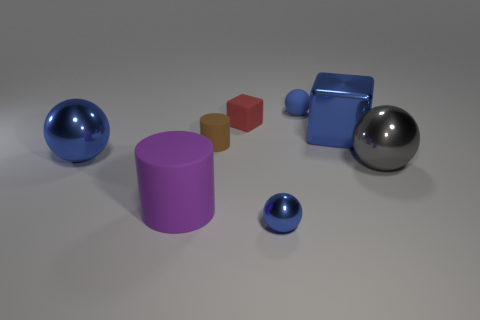What color is the large ball on the right side of the blue matte ball?
Provide a succinct answer. Gray. What number of objects are blue balls that are in front of the small red matte thing or big rubber things in front of the large gray object?
Ensure brevity in your answer.  3. How many other objects have the same shape as the big purple matte thing?
Offer a terse response. 1. What color is the block that is the same size as the purple rubber cylinder?
Your response must be concise. Blue. What is the color of the metallic sphere on the left side of the rubber object that is in front of the large ball behind the large gray metal thing?
Offer a very short reply. Blue. There is a purple rubber cylinder; is it the same size as the blue metallic object in front of the large rubber object?
Offer a terse response. No. How many objects are tiny green metallic things or brown rubber things?
Provide a short and direct response. 1. Are there any tiny blue spheres made of the same material as the tiny cylinder?
Give a very brief answer. Yes. What size is the block that is the same color as the small metal thing?
Make the answer very short. Large. What is the color of the matte cylinder in front of the shiny sphere that is left of the small blue shiny ball?
Give a very brief answer. Purple. 